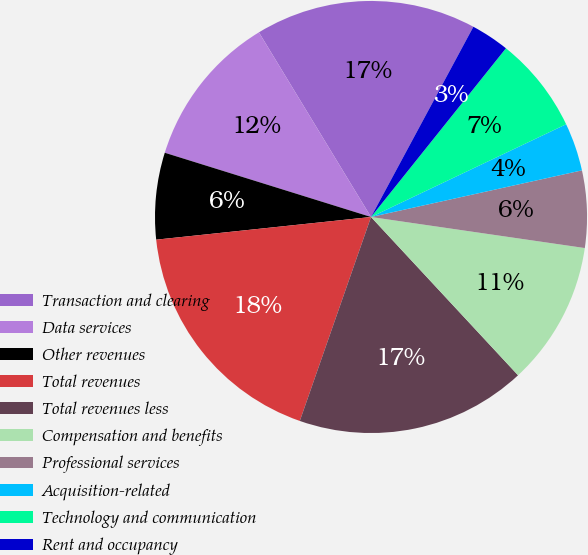<chart> <loc_0><loc_0><loc_500><loc_500><pie_chart><fcel>Transaction and clearing<fcel>Data services<fcel>Other revenues<fcel>Total revenues<fcel>Total revenues less<fcel>Compensation and benefits<fcel>Professional services<fcel>Acquisition-related<fcel>Technology and communication<fcel>Rent and occupancy<nl><fcel>16.54%<fcel>11.51%<fcel>6.48%<fcel>17.98%<fcel>17.26%<fcel>10.79%<fcel>5.76%<fcel>3.6%<fcel>7.2%<fcel>2.88%<nl></chart> 